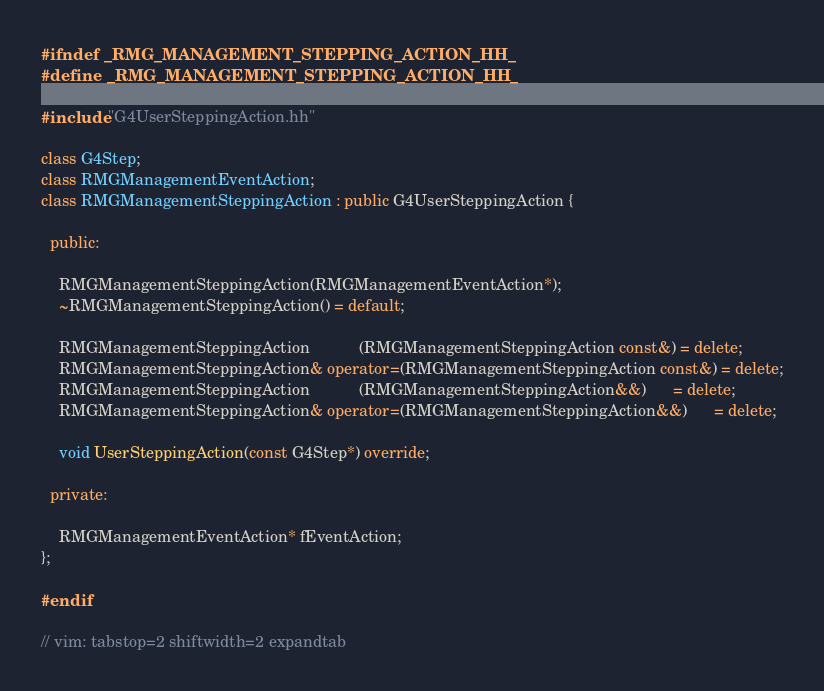<code> <loc_0><loc_0><loc_500><loc_500><_C++_>#ifndef _RMG_MANAGEMENT_STEPPING_ACTION_HH_
#define _RMG_MANAGEMENT_STEPPING_ACTION_HH_

#include "G4UserSteppingAction.hh"

class G4Step;
class RMGManagementEventAction;
class RMGManagementSteppingAction : public G4UserSteppingAction {

  public:

    RMGManagementSteppingAction(RMGManagementEventAction*);
    ~RMGManagementSteppingAction() = default;

    RMGManagementSteppingAction           (RMGManagementSteppingAction const&) = delete;
    RMGManagementSteppingAction& operator=(RMGManagementSteppingAction const&) = delete;
    RMGManagementSteppingAction           (RMGManagementSteppingAction&&)      = delete;
    RMGManagementSteppingAction& operator=(RMGManagementSteppingAction&&)      = delete;

    void UserSteppingAction(const G4Step*) override;

  private:

    RMGManagementEventAction* fEventAction;
};

#endif

// vim: tabstop=2 shiftwidth=2 expandtab
</code> 